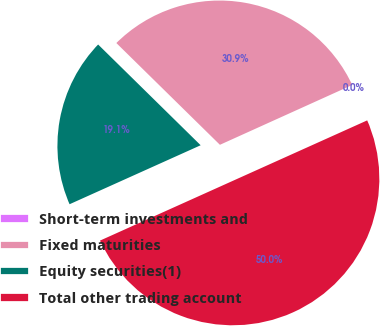<chart> <loc_0><loc_0><loc_500><loc_500><pie_chart><fcel>Short-term investments and<fcel>Fixed maturities<fcel>Equity securities(1)<fcel>Total other trading account<nl><fcel>0.03%<fcel>30.88%<fcel>19.09%<fcel>50.0%<nl></chart> 